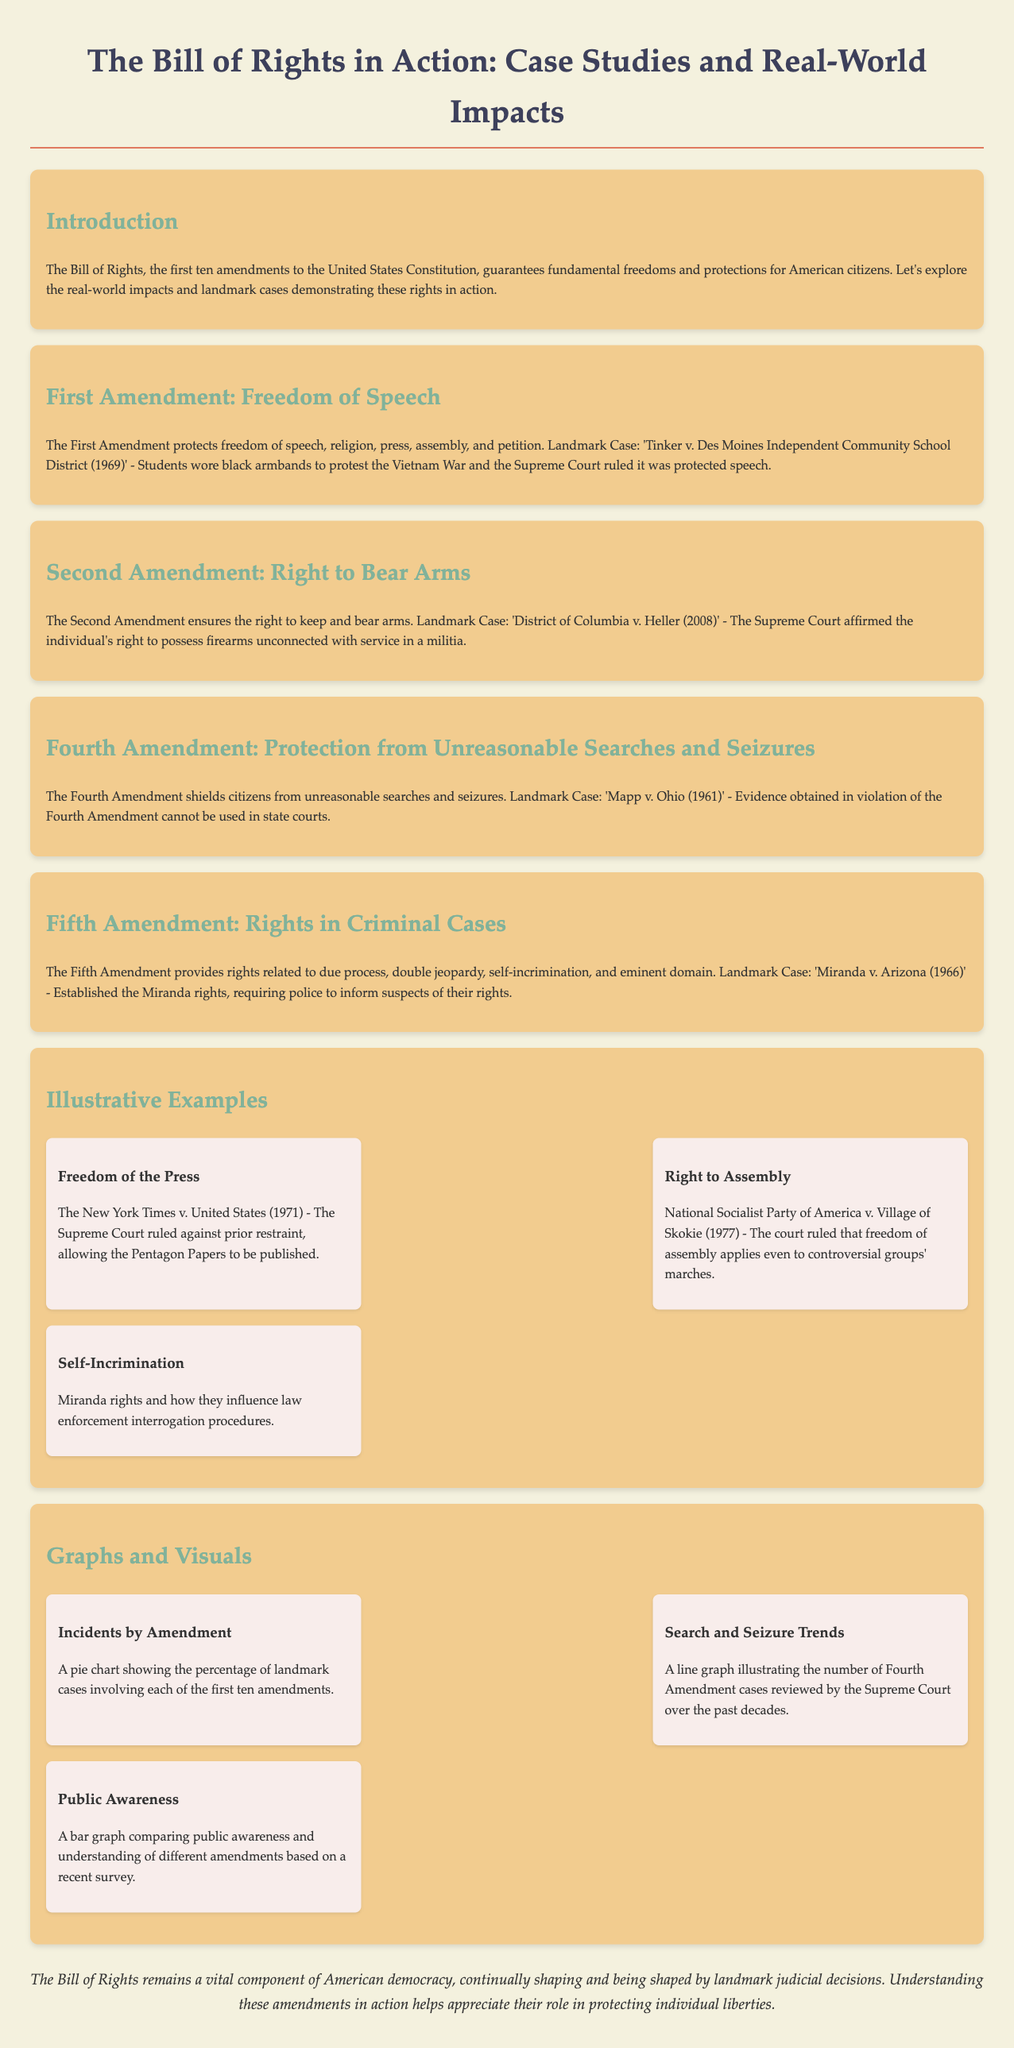what is the title of the document? The title is presented at the top of the document indicating its main subject.
Answer: The Bill of Rights in Action what amendment protects freedom of speech? The document specifies the amendment relevant to freedom of speech under its corresponding section.
Answer: First Amendment what was the landmark case for the Fifth Amendment? The document highlights significant legal cases associated with each amendment, and the Fifth Amendment is linked to a specific case.
Answer: Miranda v. Arizona which Supreme Court case involved prior restraint? The document describes landmark cases related to the First Amendment, specifically mentioning a case regarding prior restraint.
Answer: New York Times v. United States what is shown in the pie chart mentioned in the graphs section? The document alludes to specific visual data provided in the graphs and describes what type of information is presented, such as cases related to amendments.
Answer: Percentage of landmark cases what year did the Supreme Court rule on District of Columbia v. Heller? The document provides key case dates for various landmark decisions, allowing for extraction of specific years.
Answer: 2008 how many examples are listed in the Illustrative Examples section? The document outlines a specific number of examples under a titled section, which is relevant for understanding the diversity of cases.
Answer: Three which amendment is associated with protection from unreasonable searches? The document explicitly states the focus of each amendment and its corresponding protections, helping identify them accurately.
Answer: Fourth Amendment what type of graph compares public awareness? The document indicates the type of graph presented and its association with survey data related to the amendments.
Answer: Bar graph 